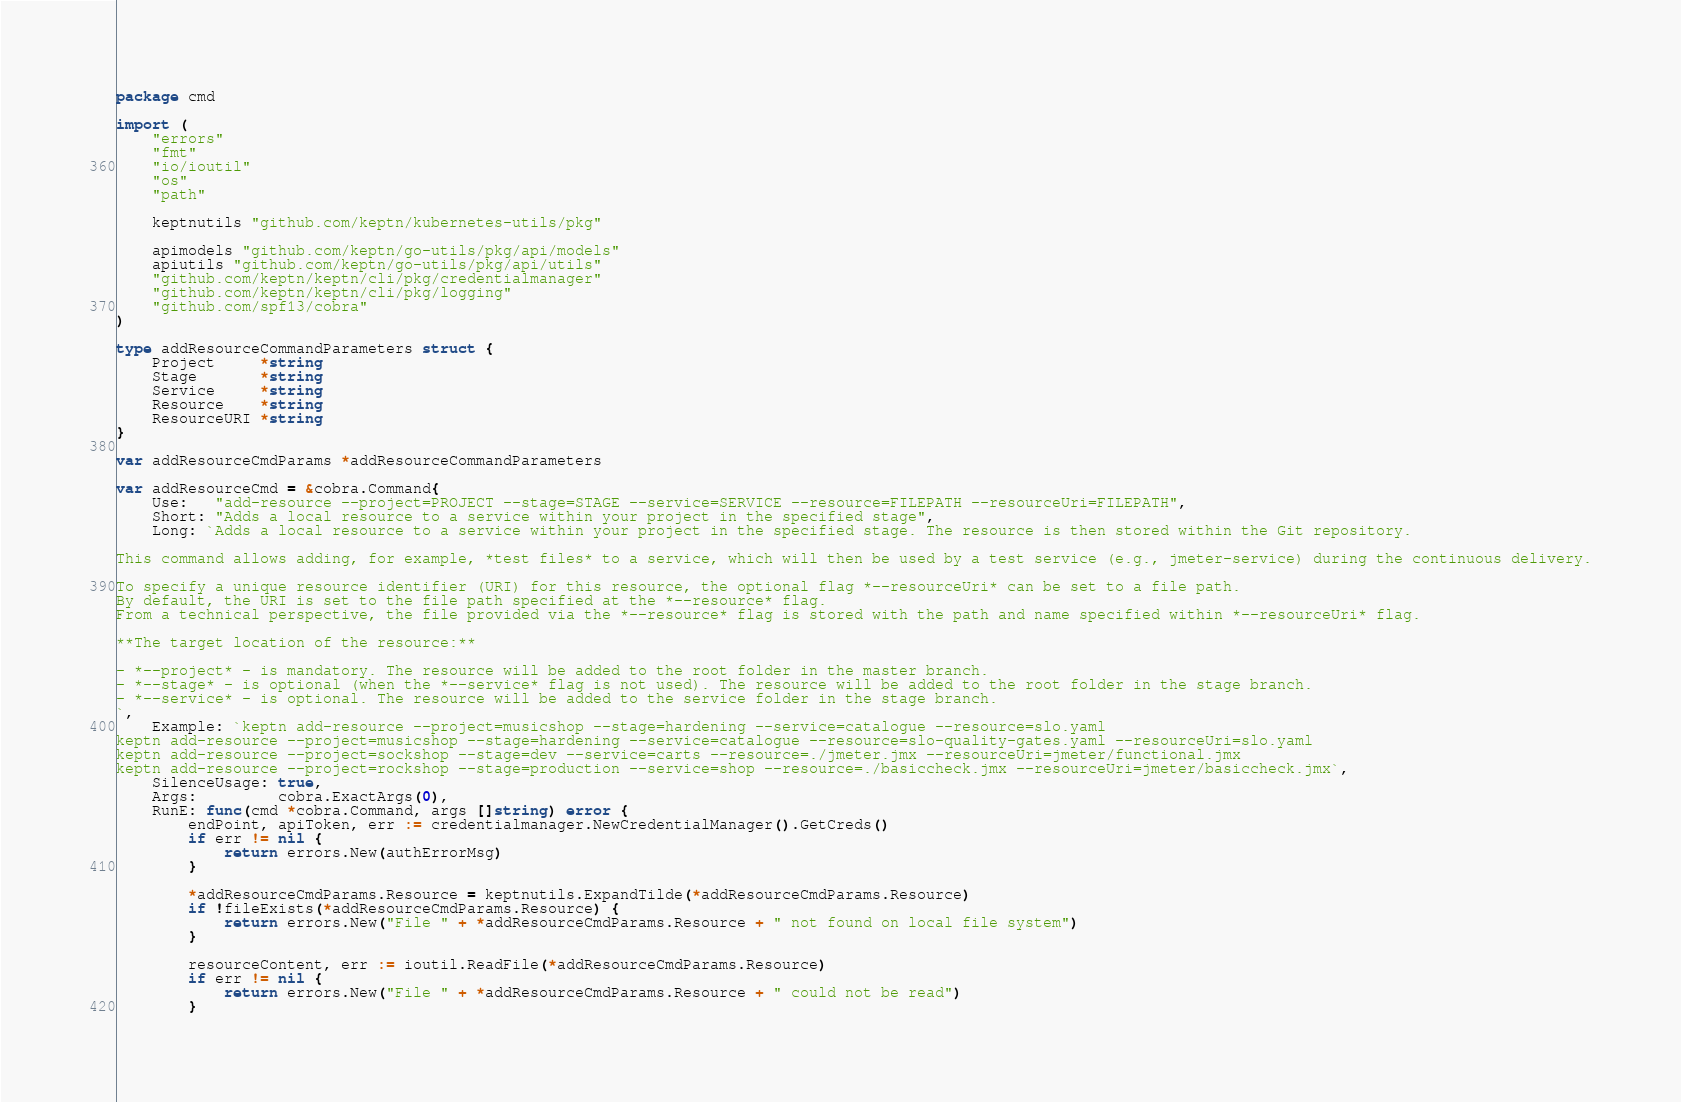<code> <loc_0><loc_0><loc_500><loc_500><_Go_>package cmd

import (
	"errors"
	"fmt"
	"io/ioutil"
	"os"
	"path"

	keptnutils "github.com/keptn/kubernetes-utils/pkg"

	apimodels "github.com/keptn/go-utils/pkg/api/models"
	apiutils "github.com/keptn/go-utils/pkg/api/utils"
	"github.com/keptn/keptn/cli/pkg/credentialmanager"
	"github.com/keptn/keptn/cli/pkg/logging"
	"github.com/spf13/cobra"
)

type addResourceCommandParameters struct {
	Project     *string
	Stage       *string
	Service     *string
	Resource    *string
	ResourceURI *string
}

var addResourceCmdParams *addResourceCommandParameters

var addResourceCmd = &cobra.Command{
	Use:   "add-resource --project=PROJECT --stage=STAGE --service=SERVICE --resource=FILEPATH --resourceUri=FILEPATH",
	Short: "Adds a local resource to a service within your project in the specified stage",
	Long: `Adds a local resource to a service within your project in the specified stage. The resource is then stored within the Git repository.

This command allows adding, for example, *test files* to a service, which will then be used by a test service (e.g., jmeter-service) during the continuous delivery.

To specify a unique resource identifier (URI) for this resource, the optional flag *--resourceUri* can be set to a file path. 
By default, the URI is set to the file path specified at the *--resource* flag. 
From a technical perspective, the file provided via the *--resource* flag is stored with the path and name specified within *--resourceUri* flag.

**The target location of the resource:**

- *--project* - is mandatory. The resource will be added to the root folder in the master branch. 
- *--stage* - is optional (when the *--service* flag is not used). The resource will be added to the root folder in the stage branch.
- *--service* - is optional. The resource will be added to the service folder in the stage branch.
`,
	Example: `keptn add-resource --project=musicshop --stage=hardening --service=catalogue --resource=slo.yaml
keptn add-resource --project=musicshop --stage=hardening --service=catalogue --resource=slo-quality-gates.yaml --resourceUri=slo.yaml
keptn add-resource --project=sockshop --stage=dev --service=carts --resource=./jmeter.jmx --resourceUri=jmeter/functional.jmx
keptn add-resource --project=rockshop --stage=production --service=shop --resource=./basiccheck.jmx --resourceUri=jmeter/basiccheck.jmx`,
	SilenceUsage: true,
	Args:         cobra.ExactArgs(0),
	RunE: func(cmd *cobra.Command, args []string) error {
		endPoint, apiToken, err := credentialmanager.NewCredentialManager().GetCreds()
		if err != nil {
			return errors.New(authErrorMsg)
		}

		*addResourceCmdParams.Resource = keptnutils.ExpandTilde(*addResourceCmdParams.Resource)
		if !fileExists(*addResourceCmdParams.Resource) {
			return errors.New("File " + *addResourceCmdParams.Resource + " not found on local file system")
		}

		resourceContent, err := ioutil.ReadFile(*addResourceCmdParams.Resource)
		if err != nil {
			return errors.New("File " + *addResourceCmdParams.Resource + " could not be read")
		}
</code> 